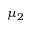Convert formula to latex. <formula><loc_0><loc_0><loc_500><loc_500>\mu _ { 2 }</formula> 